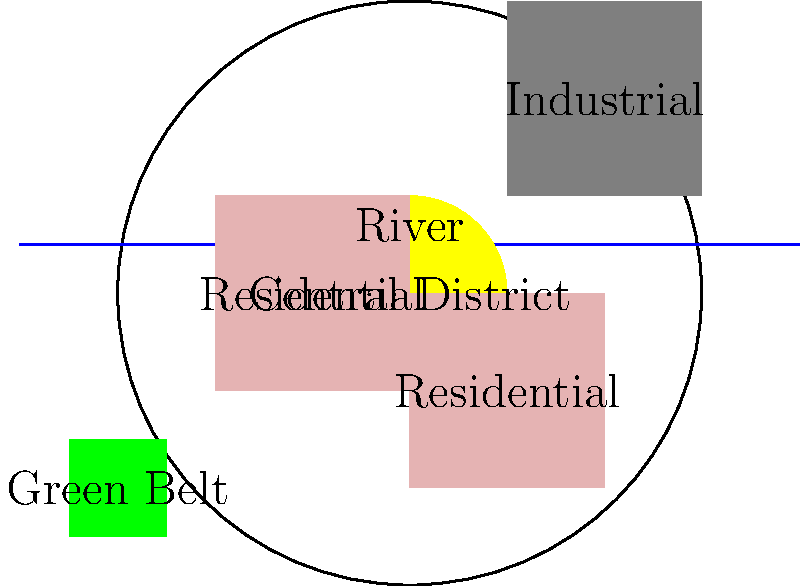As a progressive leader implementing sustainable urban planning, which key element in this city layout contributes most significantly to both environmental preservation and quality of life for residents, and how would you enhance its integration with the urban fabric? To answer this question, we need to analyze the city layout and consider the principles of sustainable urban planning:

1. Identify key elements: The layout shows a central district, residential areas, an industrial zone, a river, and a green belt.

2. Assess environmental impact: The green belt and river are the main natural elements contributing to environmental preservation.

3. Evaluate quality of life: Access to green spaces and natural water bodies significantly enhances residents' well-being.

4. Consider integration: The green belt is currently isolated at the edge of the city.

5. Determine most significant element: The green belt offers the most potential for both environmental preservation and improving quality of life.

6. Propose enhancement: To better integrate the green belt:
   a) Extend green corridors from the belt into residential areas
   b) Create a network of parks and open spaces throughout the city
   c) Implement green infrastructure to connect the belt with the river
   d) Develop sustainable transportation routes (e.g., bike paths) along these green connections

7. Consider progressive policies: Implement strict zoning laws to protect the green belt, incentivize green building practices, and promote community engagement in maintaining and expanding green spaces.
Answer: Green belt; enhance by creating a network of green corridors and open spaces throughout the city, connecting to residential areas and the river. 